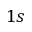<formula> <loc_0><loc_0><loc_500><loc_500>1 s</formula> 